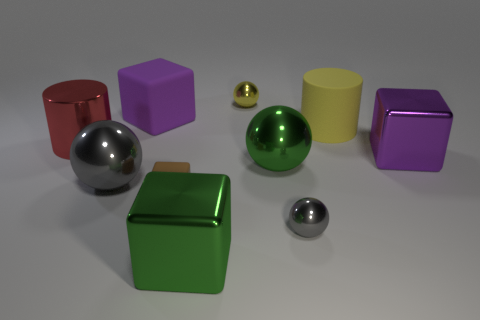Subtract all yellow balls. How many balls are left? 3 Subtract all purple cubes. How many gray balls are left? 2 Subtract all cubes. How many objects are left? 6 Subtract all yellow cylinders. How many cylinders are left? 1 Subtract 1 yellow balls. How many objects are left? 9 Subtract 2 cylinders. How many cylinders are left? 0 Subtract all yellow balls. Subtract all red cubes. How many balls are left? 3 Subtract all purple rubber objects. Subtract all small brown rubber things. How many objects are left? 8 Add 1 large rubber things. How many large rubber things are left? 3 Add 5 tiny metal cylinders. How many tiny metal cylinders exist? 5 